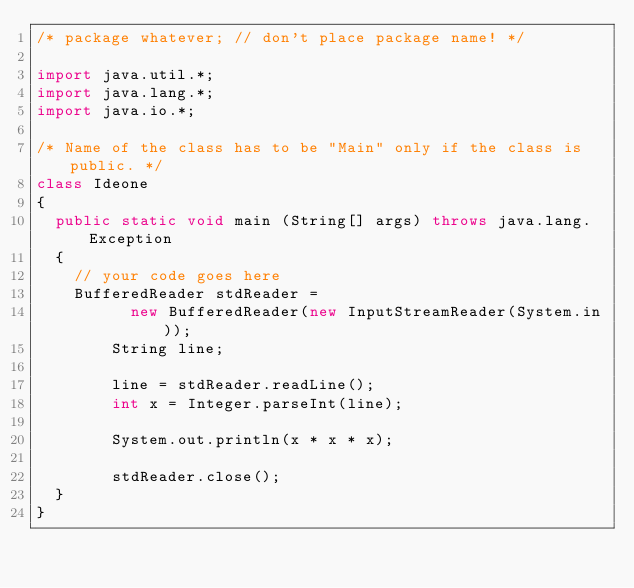<code> <loc_0><loc_0><loc_500><loc_500><_Java_>/* package whatever; // don't place package name! */

import java.util.*;
import java.lang.*;
import java.io.*;

/* Name of the class has to be "Main" only if the class is public. */
class Ideone
{
	public static void main (String[] args) throws java.lang.Exception
	{
		// your code goes here
		BufferedReader stdReader =
        	new BufferedReader(new InputStreamReader(System.in));
      	String line;
      	
      	line = stdReader.readLine();
      	int x = Integer.parseInt(line);
      	
      	System.out.println(x * x * x);
      	
      	stdReader.close();
	}
}</code> 